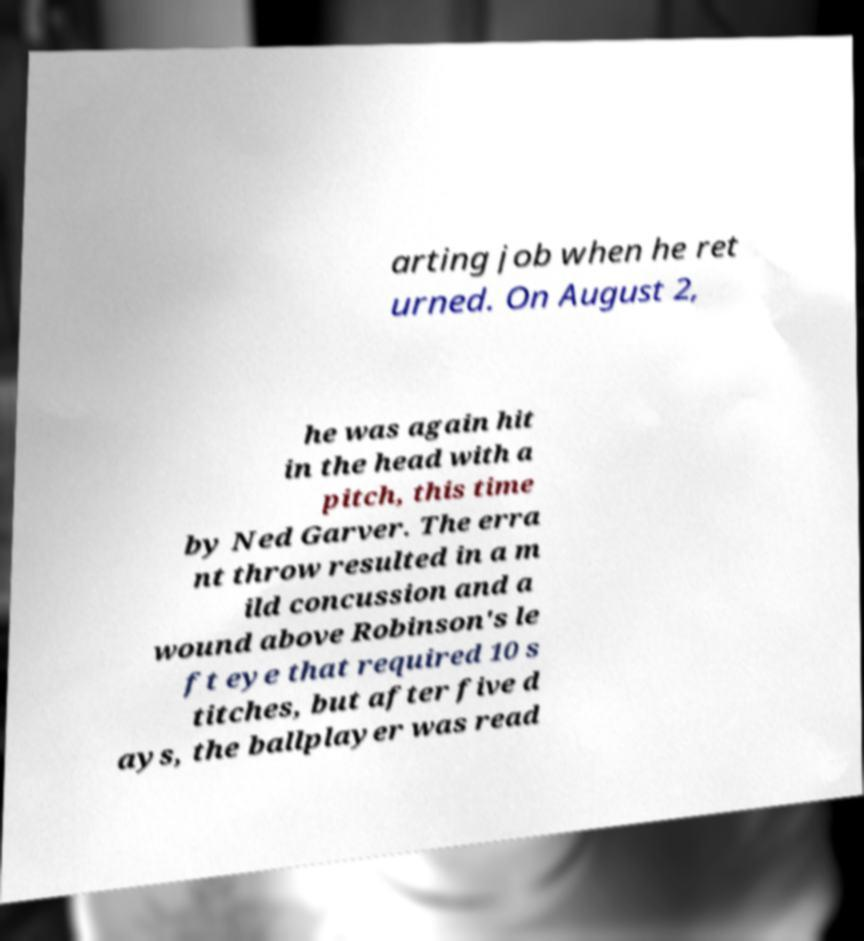I need the written content from this picture converted into text. Can you do that? arting job when he ret urned. On August 2, he was again hit in the head with a pitch, this time by Ned Garver. The erra nt throw resulted in a m ild concussion and a wound above Robinson's le ft eye that required 10 s titches, but after five d ays, the ballplayer was read 